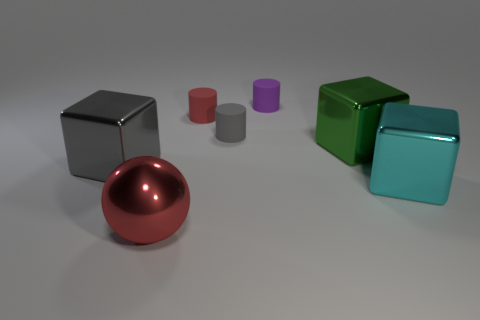Subtract 1 blocks. How many blocks are left? 2 Add 2 small purple spheres. How many objects exist? 9 Subtract all cylinders. How many objects are left? 4 Subtract all yellow cylinders. Subtract all gray blocks. How many cylinders are left? 3 Add 3 cubes. How many cubes are left? 6 Add 2 big green shiny blocks. How many big green shiny blocks exist? 3 Subtract 1 red spheres. How many objects are left? 6 Subtract all gray shiny things. Subtract all big yellow matte cylinders. How many objects are left? 6 